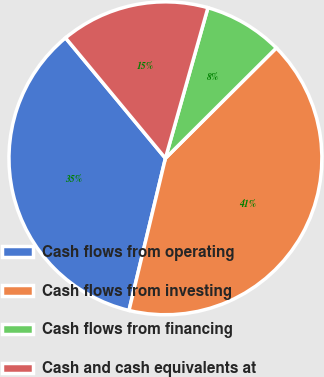Convert chart to OTSL. <chart><loc_0><loc_0><loc_500><loc_500><pie_chart><fcel>Cash flows from operating<fcel>Cash flows from investing<fcel>Cash flows from financing<fcel>Cash and cash equivalents at<nl><fcel>35.24%<fcel>41.2%<fcel>8.16%<fcel>15.4%<nl></chart> 